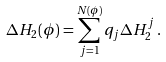Convert formula to latex. <formula><loc_0><loc_0><loc_500><loc_500>\Delta H _ { 2 } ( \phi ) = \sum _ { j = 1 } ^ { N ( \phi ) } q _ { j } \Delta H _ { 2 } ^ { j } \, .</formula> 